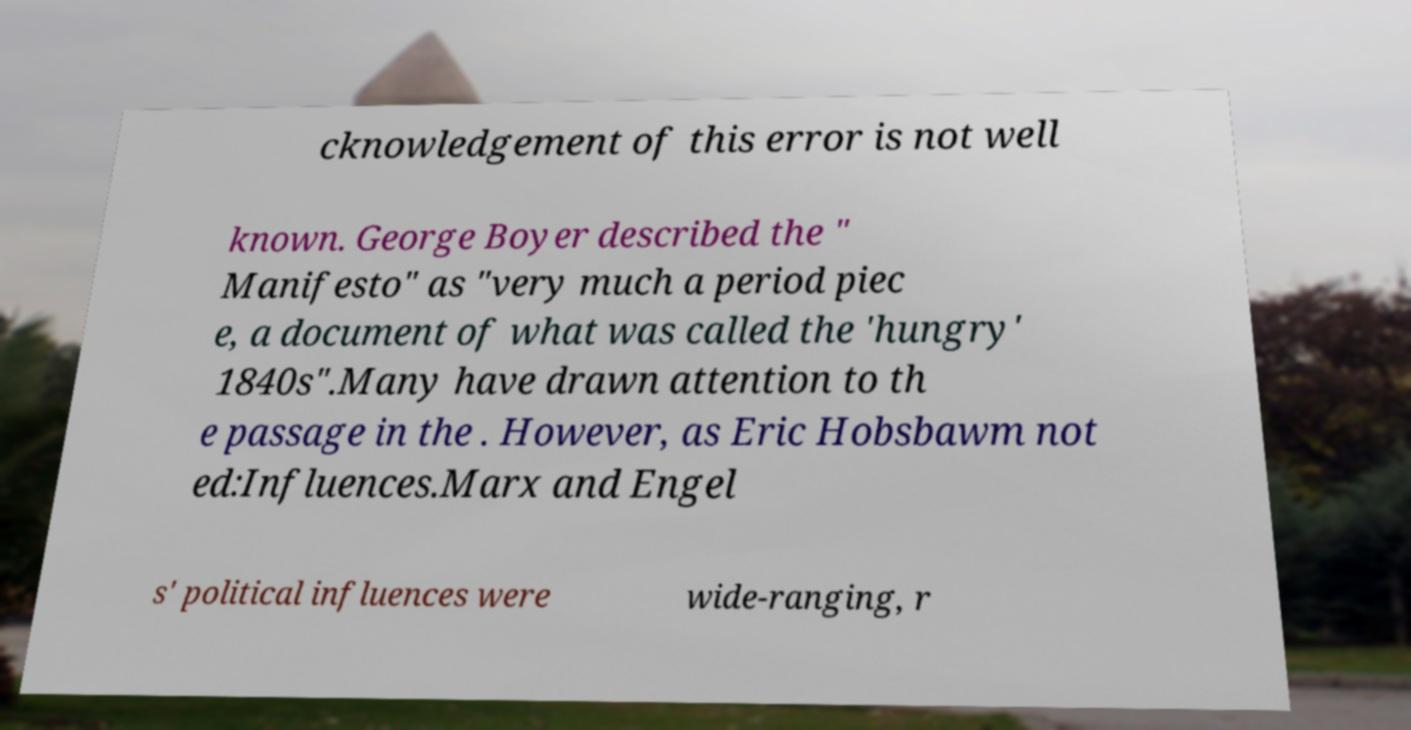I need the written content from this picture converted into text. Can you do that? cknowledgement of this error is not well known. George Boyer described the " Manifesto" as "very much a period piec e, a document of what was called the 'hungry' 1840s".Many have drawn attention to th e passage in the . However, as Eric Hobsbawm not ed:Influences.Marx and Engel s' political influences were wide-ranging, r 